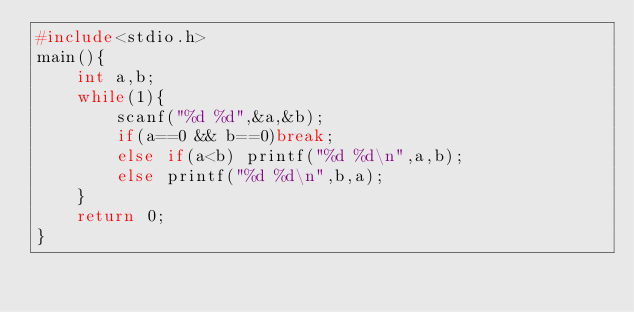<code> <loc_0><loc_0><loc_500><loc_500><_C_>#include<stdio.h>
main(){
	int a,b;
	while(1){
		scanf("%d %d",&a,&b);
		if(a==0 && b==0)break;
		else if(a<b) printf("%d %d\n",a,b);
		else printf("%d %d\n",b,a);
	}
	return 0;
}</code> 